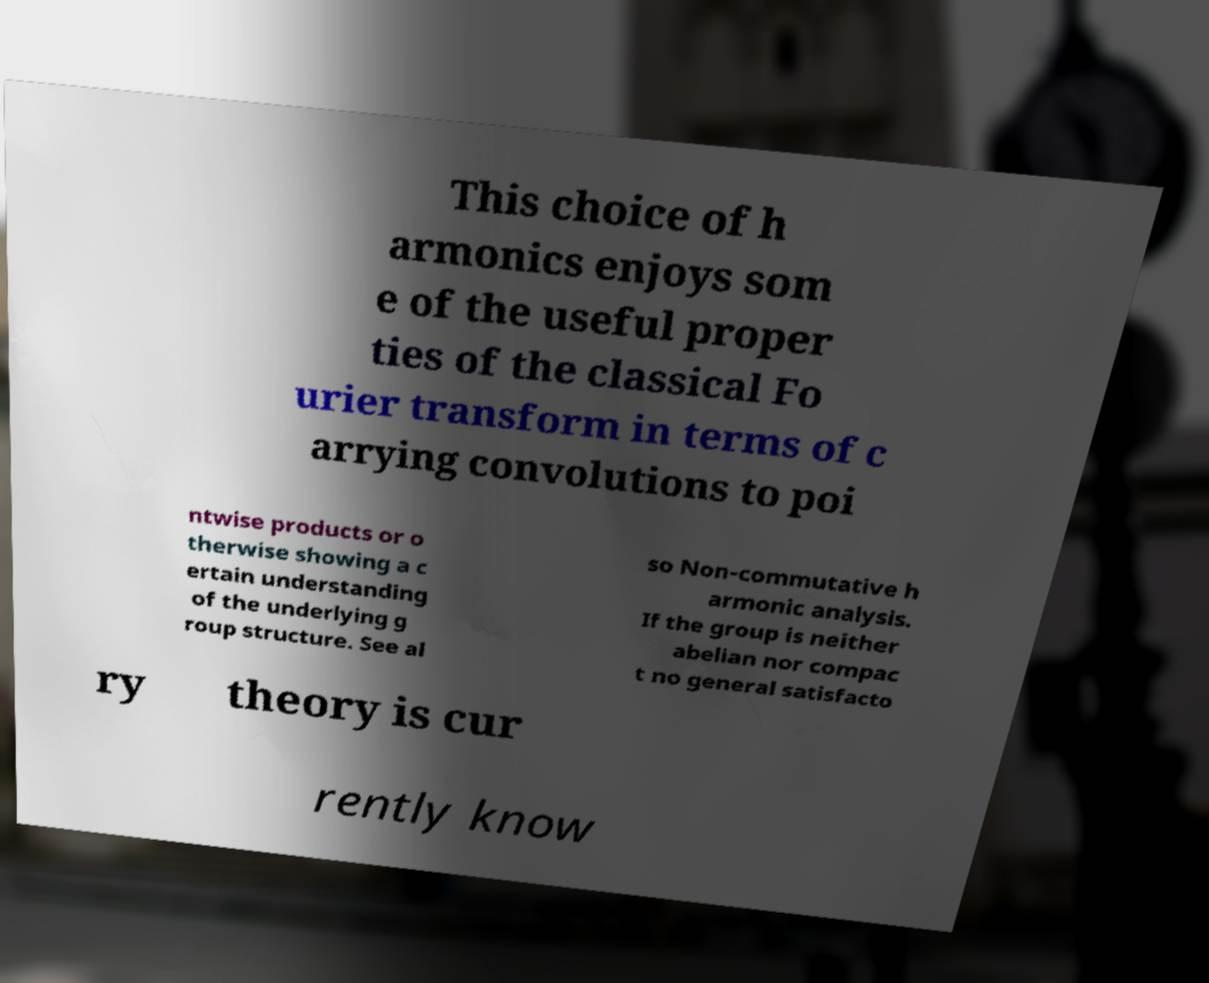Could you assist in decoding the text presented in this image and type it out clearly? This choice of h armonics enjoys som e of the useful proper ties of the classical Fo urier transform in terms of c arrying convolutions to poi ntwise products or o therwise showing a c ertain understanding of the underlying g roup structure. See al so Non-commutative h armonic analysis. If the group is neither abelian nor compac t no general satisfacto ry theory is cur rently know 